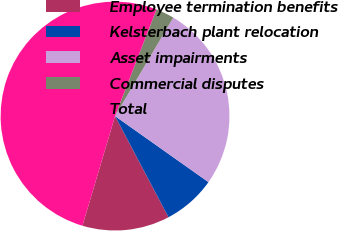<chart> <loc_0><loc_0><loc_500><loc_500><pie_chart><fcel>Employee termination benefits<fcel>Kelsterbach plant relocation<fcel>Asset impairments<fcel>Commercial disputes<fcel>Total<nl><fcel>12.34%<fcel>7.47%<fcel>26.3%<fcel>2.6%<fcel>51.3%<nl></chart> 